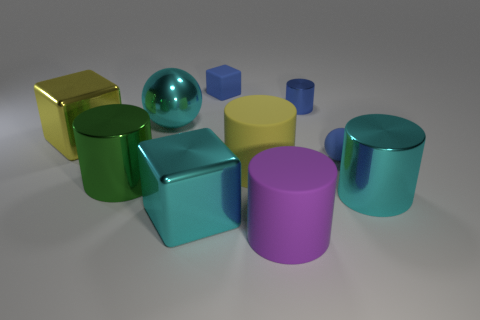How big is the cylinder in front of the large object that is on the right side of the sphere that is in front of the large sphere?
Ensure brevity in your answer.  Large. What number of green things are either small blocks or metallic cylinders?
Offer a terse response. 1. Are the large cyan cylinder and the large yellow thing on the right side of the large cyan sphere made of the same material?
Give a very brief answer. No. Are there the same number of cyan cubes that are behind the large yellow block and large yellow objects that are in front of the big green object?
Your answer should be compact. Yes. There is a yellow rubber cylinder; is it the same size as the blue rubber object that is in front of the blue metallic object?
Give a very brief answer. No. Is the number of metallic cubes that are behind the big cyan cylinder greater than the number of tiny brown rubber blocks?
Your answer should be very brief. Yes. What number of balls are the same size as the blue cylinder?
Make the answer very short. 1. Do the shiny block to the right of the green shiny cylinder and the matte thing behind the cyan metal sphere have the same size?
Your response must be concise. No. Are there more big metal objects that are left of the tiny blue cylinder than cyan metallic blocks that are behind the tiny ball?
Provide a succinct answer. Yes. What number of other metal objects have the same shape as the purple object?
Your answer should be very brief. 3. 